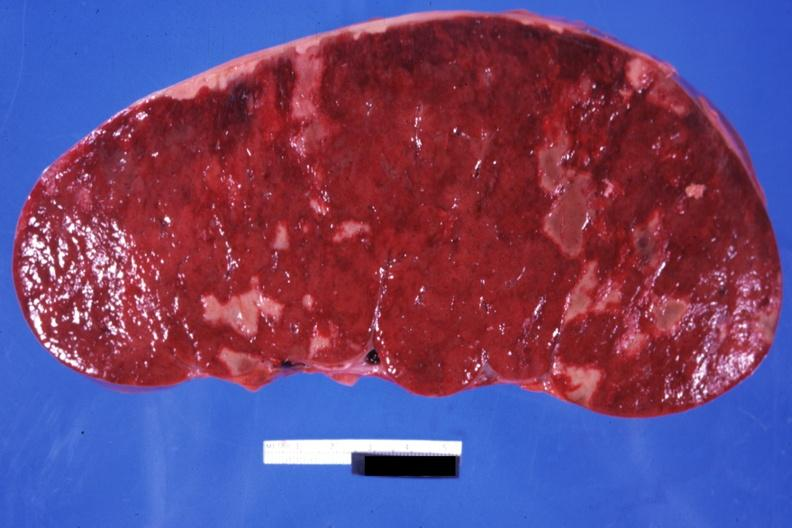how does this image show very enlarged spleen?
Answer the question using a single word or phrase. With multiple infarcts infiltrative process is easily seen 